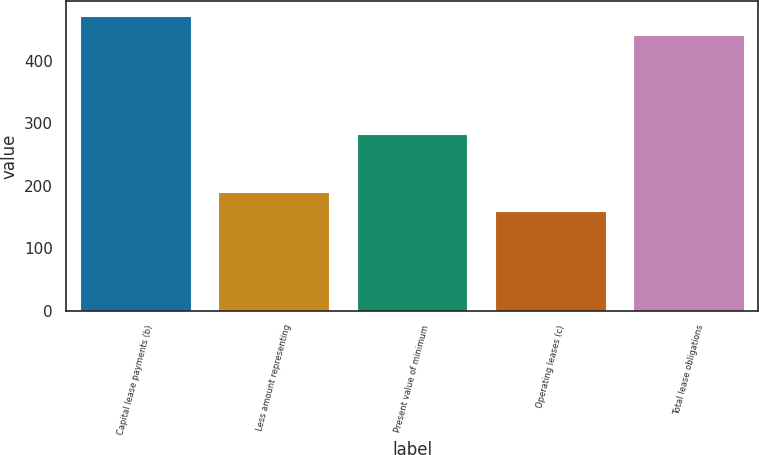Convert chart. <chart><loc_0><loc_0><loc_500><loc_500><bar_chart><fcel>Capital lease payments (b)<fcel>Less amount representing<fcel>Present value of minimum<fcel>Operating leases (c)<fcel>Total lease obligations<nl><fcel>471.8<fcel>189.8<fcel>282<fcel>160<fcel>442<nl></chart> 